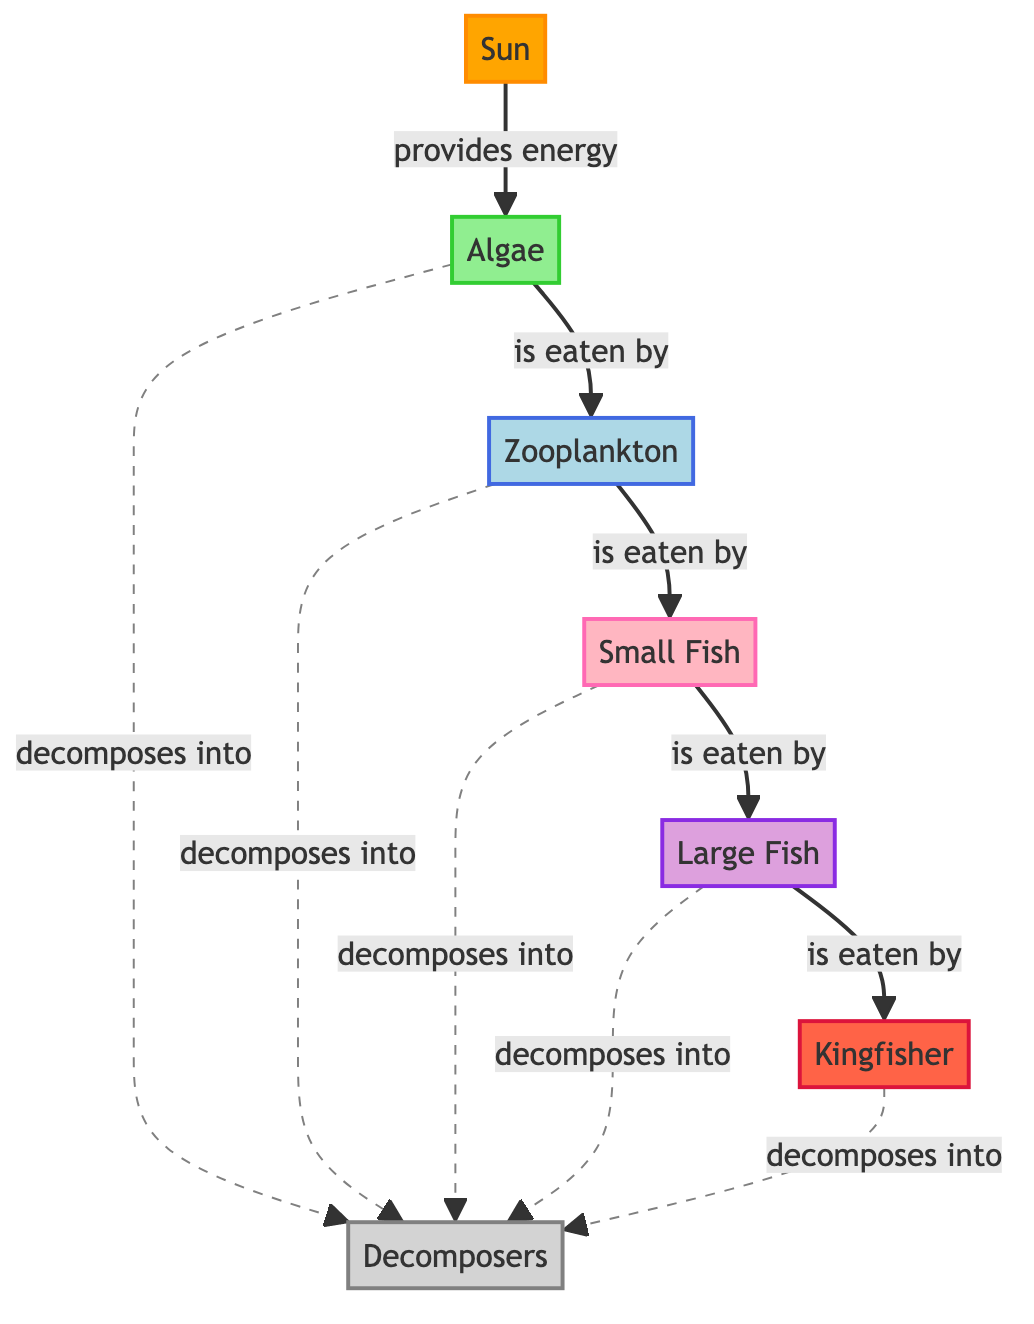What is the primary producer in the Seyhan River Ecosystem? The diagram indicates that algae is the primary producer, as it is directly connected to the sun that provides energy.
Answer: Algae How many trophic levels are depicted in the diagram? The diagram shows five trophic levels, starting from the sun (energy source) and including algae, zooplankton, small fish, large fish, and kingfisher.
Answer: Five Which organism is the apex predator in this ecosystem? The kingfisher is identified as the apex predator, as it is at the top of the food chain in the diagram.
Answer: Kingfisher What consumes zooplankton in this ecosystem? The diagram shows that small fish consume zooplankton. This can be inferred from the direct connection between these two nodes in the flowchart.
Answer: Small Fish What role do decomposers play in this ecosystem? Decomposers are responsible for breaking down all the organisms when they die, as indicated by the dashed lines showing connections from each organism to the decomposers.
Answer: Breakdown of dead organisms Which organisms are connected through the energy transfer process identified in the diagram? The energy transfer process involves multiple organisms: from the sun to algae, algae to zooplankton, zooplankton to small fish, small fish to large fish, and finally, large fish to kingfisher.
Answer: Sun, Algae, Zooplankton, Small Fish, Large Fish, Kingfisher What happens to dead organisms in this ecosystem according to the diagram? Dead organisms decompose into decomposers, which is represented by the dashed lines from each organism in the ecosystem to the decomposers.
Answer: Decompose into decomposers How does energy flow from the sun to the kingfisher? Energy flows from the sun to algae, then to zooplankton, followed by small fish, then large fish, and finally to the kingfisher, highlighting the sequential nature of energy transfer in this ecosystem.
Answer: Through multiple organisms: Sun → Algae → Zooplankton → Small Fish → Large Fish → Kingfisher 